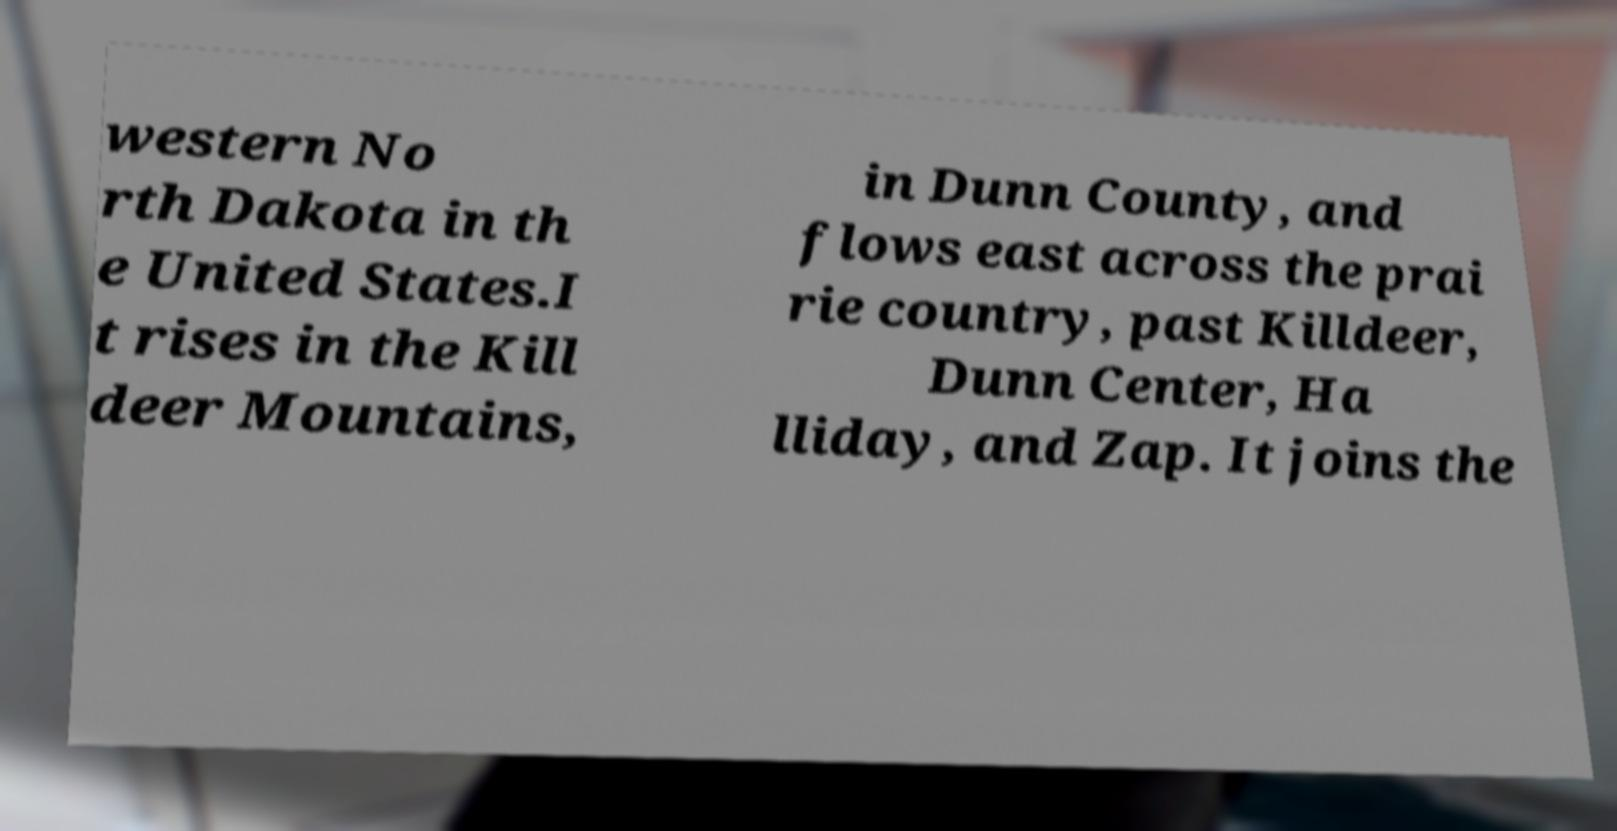I need the written content from this picture converted into text. Can you do that? western No rth Dakota in th e United States.I t rises in the Kill deer Mountains, in Dunn County, and flows east across the prai rie country, past Killdeer, Dunn Center, Ha lliday, and Zap. It joins the 